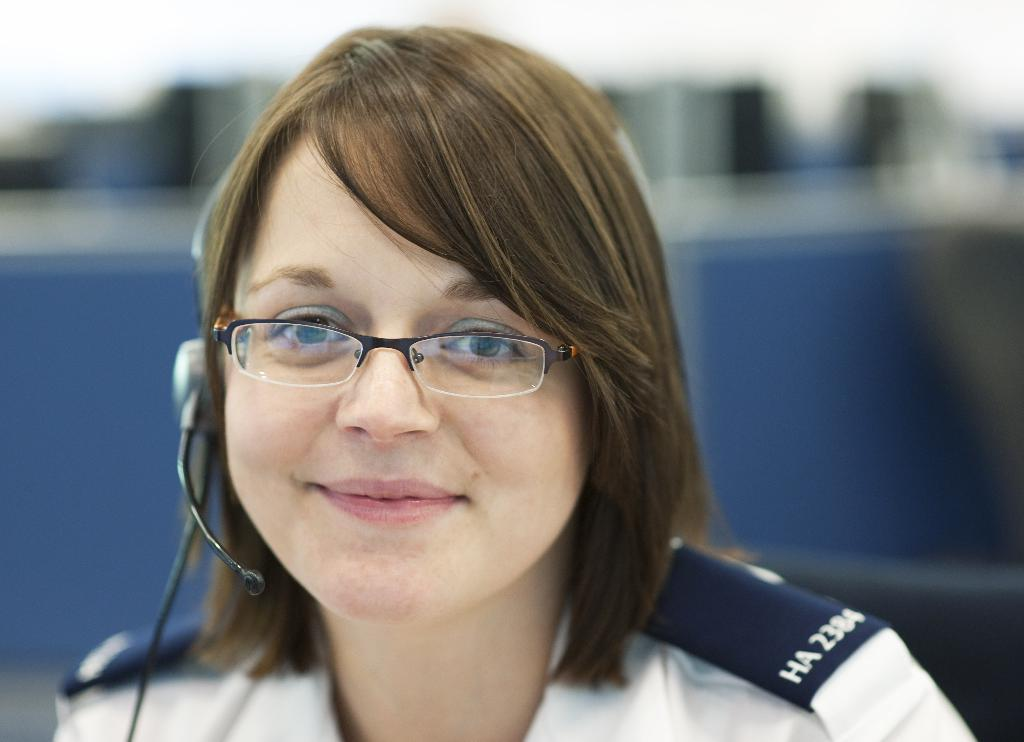Who is present in the image? There is a woman in the image. What is the woman wearing on her head? The woman is wearing a headphone. Can you describe the background of the image? The background of the image is blurred. How many birds can be seen laying eggs in the image? There are no birds or eggs present in the image. 